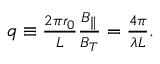Convert formula to latex. <formula><loc_0><loc_0><loc_500><loc_500>\begin{array} { r } { q \equiv \frac { 2 \pi r _ { 0 } } { L } \frac { B _ { \| } } { B _ { T } } = \frac { 4 \pi } { \lambda L } . } \end{array}</formula> 